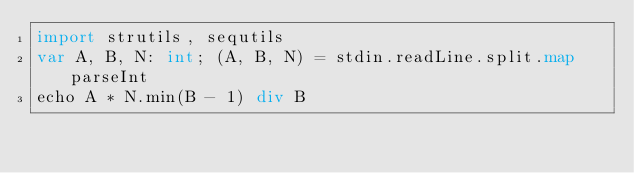<code> <loc_0><loc_0><loc_500><loc_500><_Nim_>import strutils, sequtils
var A, B, N: int; (A, B, N) = stdin.readLine.split.map parseInt
echo A * N.min(B - 1) div B</code> 